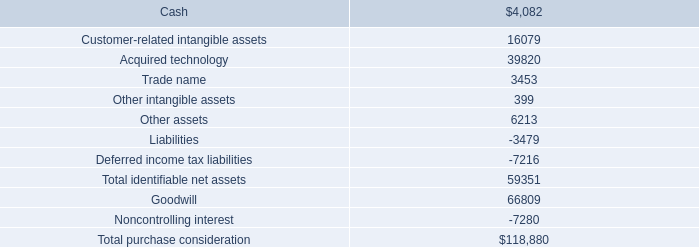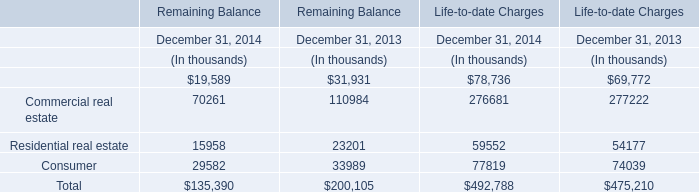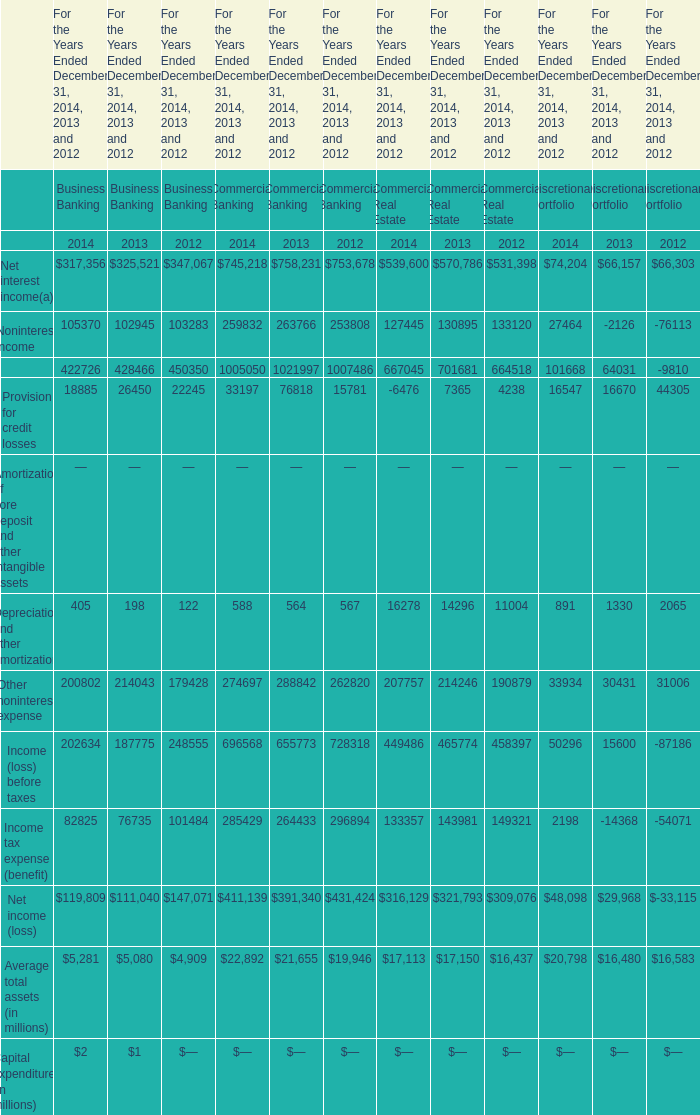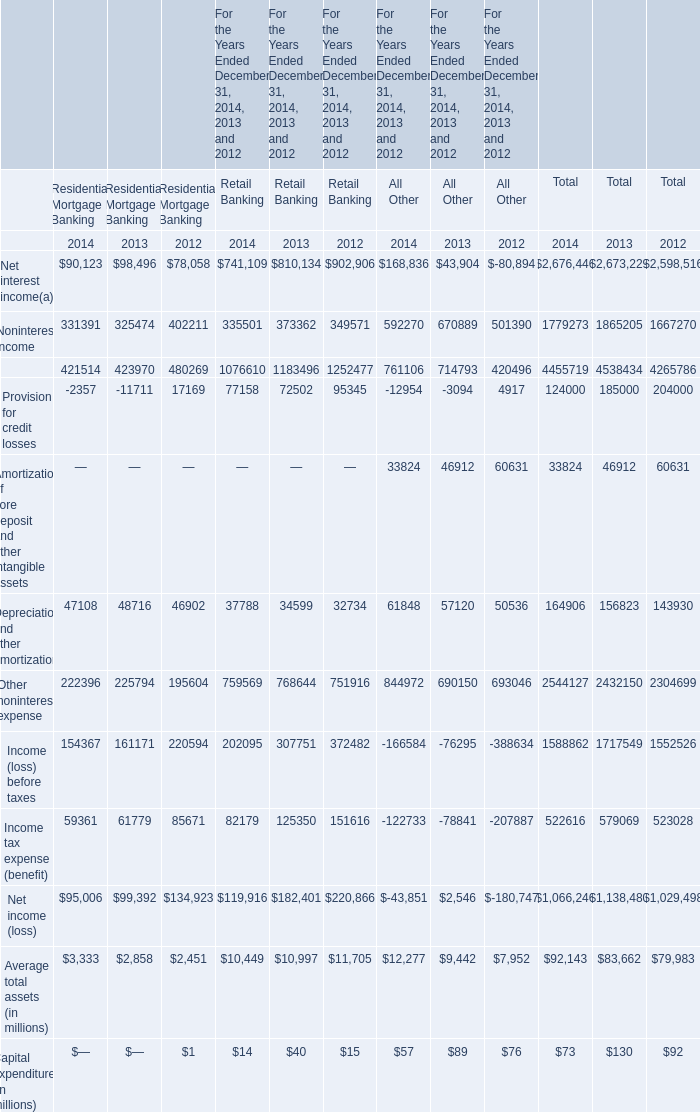Which year is Depreciation and other amortization for Commercial Banking the highest? 
Answer: 2014. 